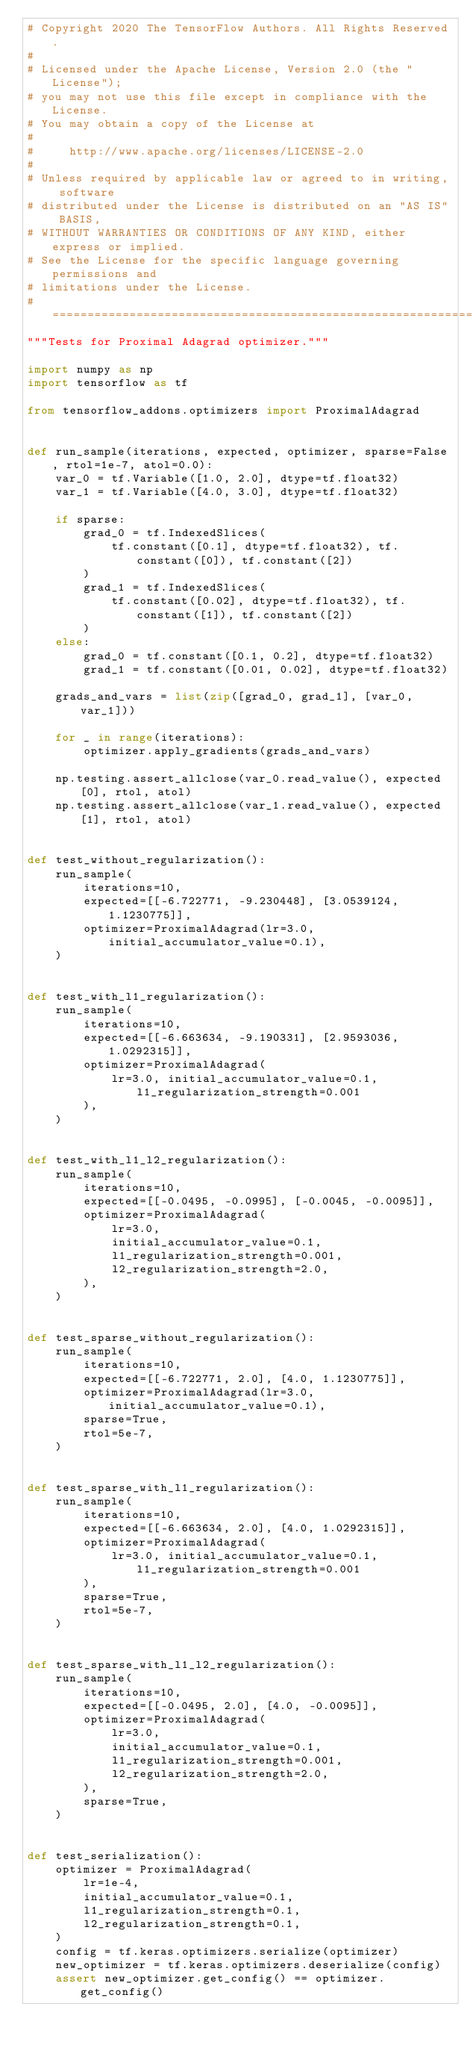Convert code to text. <code><loc_0><loc_0><loc_500><loc_500><_Python_># Copyright 2020 The TensorFlow Authors. All Rights Reserved.
#
# Licensed under the Apache License, Version 2.0 (the "License");
# you may not use this file except in compliance with the License.
# You may obtain a copy of the License at
#
#     http://www.apache.org/licenses/LICENSE-2.0
#
# Unless required by applicable law or agreed to in writing, software
# distributed under the License is distributed on an "AS IS" BASIS,
# WITHOUT WARRANTIES OR CONDITIONS OF ANY KIND, either express or implied.
# See the License for the specific language governing permissions and
# limitations under the License.
# ==============================================================================
"""Tests for Proximal Adagrad optimizer."""

import numpy as np
import tensorflow as tf

from tensorflow_addons.optimizers import ProximalAdagrad


def run_sample(iterations, expected, optimizer, sparse=False, rtol=1e-7, atol=0.0):
    var_0 = tf.Variable([1.0, 2.0], dtype=tf.float32)
    var_1 = tf.Variable([4.0, 3.0], dtype=tf.float32)

    if sparse:
        grad_0 = tf.IndexedSlices(
            tf.constant([0.1], dtype=tf.float32), tf.constant([0]), tf.constant([2])
        )
        grad_1 = tf.IndexedSlices(
            tf.constant([0.02], dtype=tf.float32), tf.constant([1]), tf.constant([2])
        )
    else:
        grad_0 = tf.constant([0.1, 0.2], dtype=tf.float32)
        grad_1 = tf.constant([0.01, 0.02], dtype=tf.float32)

    grads_and_vars = list(zip([grad_0, grad_1], [var_0, var_1]))

    for _ in range(iterations):
        optimizer.apply_gradients(grads_and_vars)

    np.testing.assert_allclose(var_0.read_value(), expected[0], rtol, atol)
    np.testing.assert_allclose(var_1.read_value(), expected[1], rtol, atol)


def test_without_regularization():
    run_sample(
        iterations=10,
        expected=[[-6.722771, -9.230448], [3.0539124, 1.1230775]],
        optimizer=ProximalAdagrad(lr=3.0, initial_accumulator_value=0.1),
    )


def test_with_l1_regularization():
    run_sample(
        iterations=10,
        expected=[[-6.663634, -9.190331], [2.9593036, 1.0292315]],
        optimizer=ProximalAdagrad(
            lr=3.0, initial_accumulator_value=0.1, l1_regularization_strength=0.001
        ),
    )


def test_with_l1_l2_regularization():
    run_sample(
        iterations=10,
        expected=[[-0.0495, -0.0995], [-0.0045, -0.0095]],
        optimizer=ProximalAdagrad(
            lr=3.0,
            initial_accumulator_value=0.1,
            l1_regularization_strength=0.001,
            l2_regularization_strength=2.0,
        ),
    )


def test_sparse_without_regularization():
    run_sample(
        iterations=10,
        expected=[[-6.722771, 2.0], [4.0, 1.1230775]],
        optimizer=ProximalAdagrad(lr=3.0, initial_accumulator_value=0.1),
        sparse=True,
        rtol=5e-7,
    )


def test_sparse_with_l1_regularization():
    run_sample(
        iterations=10,
        expected=[[-6.663634, 2.0], [4.0, 1.0292315]],
        optimizer=ProximalAdagrad(
            lr=3.0, initial_accumulator_value=0.1, l1_regularization_strength=0.001
        ),
        sparse=True,
        rtol=5e-7,
    )


def test_sparse_with_l1_l2_regularization():
    run_sample(
        iterations=10,
        expected=[[-0.0495, 2.0], [4.0, -0.0095]],
        optimizer=ProximalAdagrad(
            lr=3.0,
            initial_accumulator_value=0.1,
            l1_regularization_strength=0.001,
            l2_regularization_strength=2.0,
        ),
        sparse=True,
    )


def test_serialization():
    optimizer = ProximalAdagrad(
        lr=1e-4,
        initial_accumulator_value=0.1,
        l1_regularization_strength=0.1,
        l2_regularization_strength=0.1,
    )
    config = tf.keras.optimizers.serialize(optimizer)
    new_optimizer = tf.keras.optimizers.deserialize(config)
    assert new_optimizer.get_config() == optimizer.get_config()
</code> 